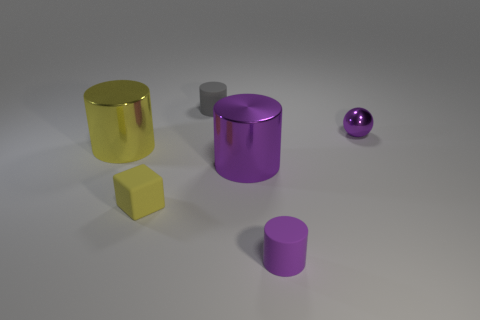There is a small purple thing that is the same shape as the tiny gray matte thing; what is its material?
Make the answer very short. Rubber. There is a tiny matte block; is it the same color as the matte cylinder that is behind the small metal ball?
Make the answer very short. No. There is another cylinder that is the same size as the gray cylinder; what material is it?
Offer a very short reply. Rubber. Is there another purple ball that has the same material as the tiny ball?
Offer a very short reply. No. How many purple shiny balls are there?
Your answer should be compact. 1. Is the large purple cylinder made of the same material as the large cylinder left of the tiny gray rubber cylinder?
Your answer should be compact. Yes. There is a big object that is the same color as the tiny shiny thing; what is it made of?
Your answer should be very brief. Metal. How many metallic spheres are the same color as the block?
Offer a very short reply. 0. The purple rubber thing has what size?
Your answer should be compact. Small. There is a purple matte thing; does it have the same shape as the big thing that is on the right side of the tiny rubber block?
Make the answer very short. Yes. 